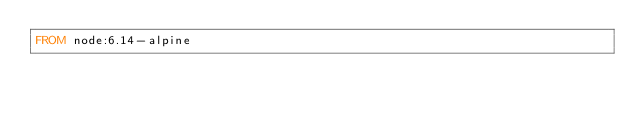Convert code to text. <code><loc_0><loc_0><loc_500><loc_500><_Dockerfile_>FROM node:6.14-alpine
</code> 